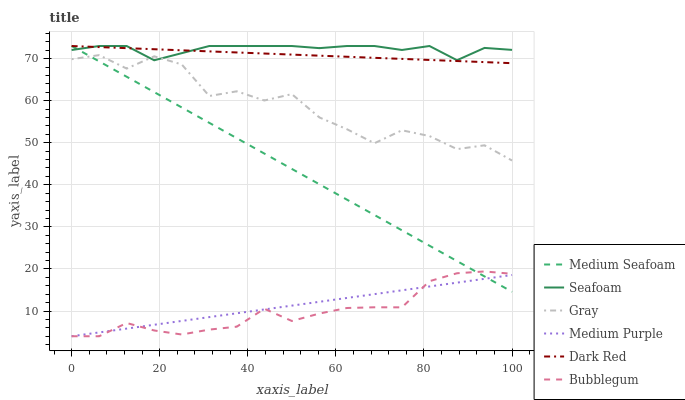Does Dark Red have the minimum area under the curve?
Answer yes or no. No. Does Dark Red have the maximum area under the curve?
Answer yes or no. No. Is Dark Red the smoothest?
Answer yes or no. No. Is Dark Red the roughest?
Answer yes or no. No. Does Dark Red have the lowest value?
Answer yes or no. No. Does Bubblegum have the highest value?
Answer yes or no. No. Is Bubblegum less than Seafoam?
Answer yes or no. Yes. Is Gray greater than Bubblegum?
Answer yes or no. Yes. Does Bubblegum intersect Seafoam?
Answer yes or no. No. 